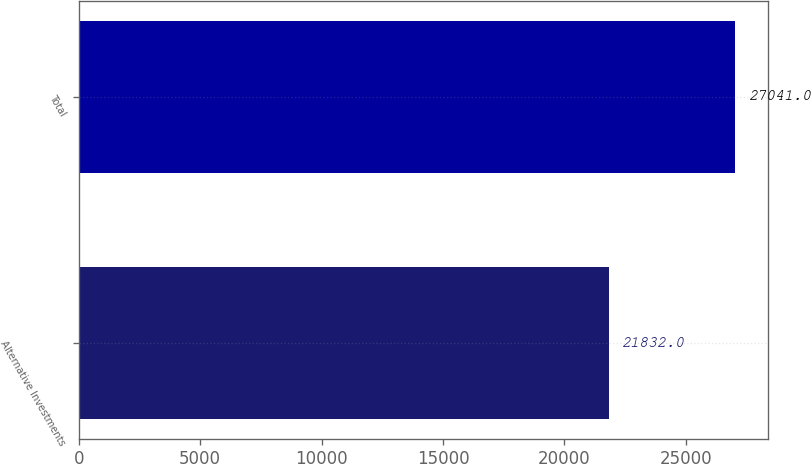<chart> <loc_0><loc_0><loc_500><loc_500><bar_chart><fcel>Alternative Investments<fcel>Total<nl><fcel>21832<fcel>27041<nl></chart> 